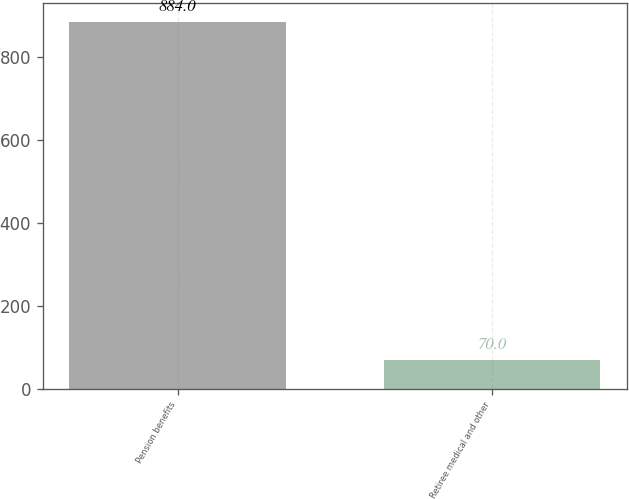Convert chart. <chart><loc_0><loc_0><loc_500><loc_500><bar_chart><fcel>Pension benefits<fcel>Retiree medical and other<nl><fcel>884<fcel>70<nl></chart> 